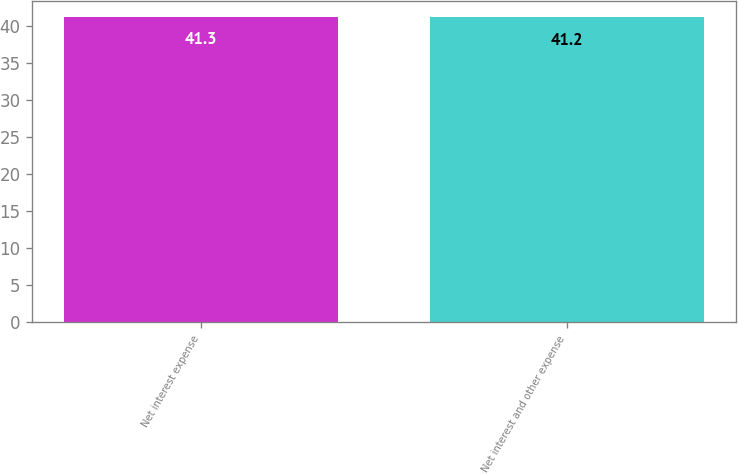Convert chart to OTSL. <chart><loc_0><loc_0><loc_500><loc_500><bar_chart><fcel>Net interest expense<fcel>Net interest and other expense<nl><fcel>41.3<fcel>41.2<nl></chart> 